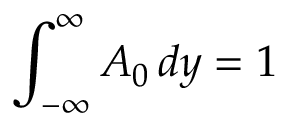Convert formula to latex. <formula><loc_0><loc_0><loc_500><loc_500>\int _ { - \infty } ^ { \infty } A _ { 0 } \, d y = 1</formula> 